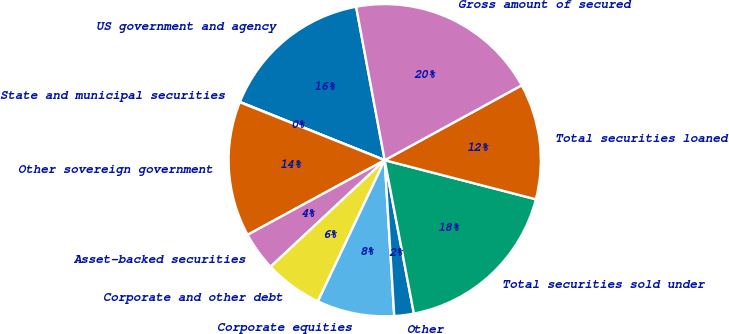Convert chart. <chart><loc_0><loc_0><loc_500><loc_500><pie_chart><fcel>US government and agency<fcel>State and municipal securities<fcel>Other sovereign government<fcel>Asset-backed securities<fcel>Corporate and other debt<fcel>Corporate equities<fcel>Other<fcel>Total securities sold under<fcel>Total securities loaned<fcel>Gross amount of secured<nl><fcel>15.98%<fcel>0.03%<fcel>13.99%<fcel>4.02%<fcel>6.01%<fcel>8.01%<fcel>2.02%<fcel>17.98%<fcel>11.99%<fcel>19.97%<nl></chart> 